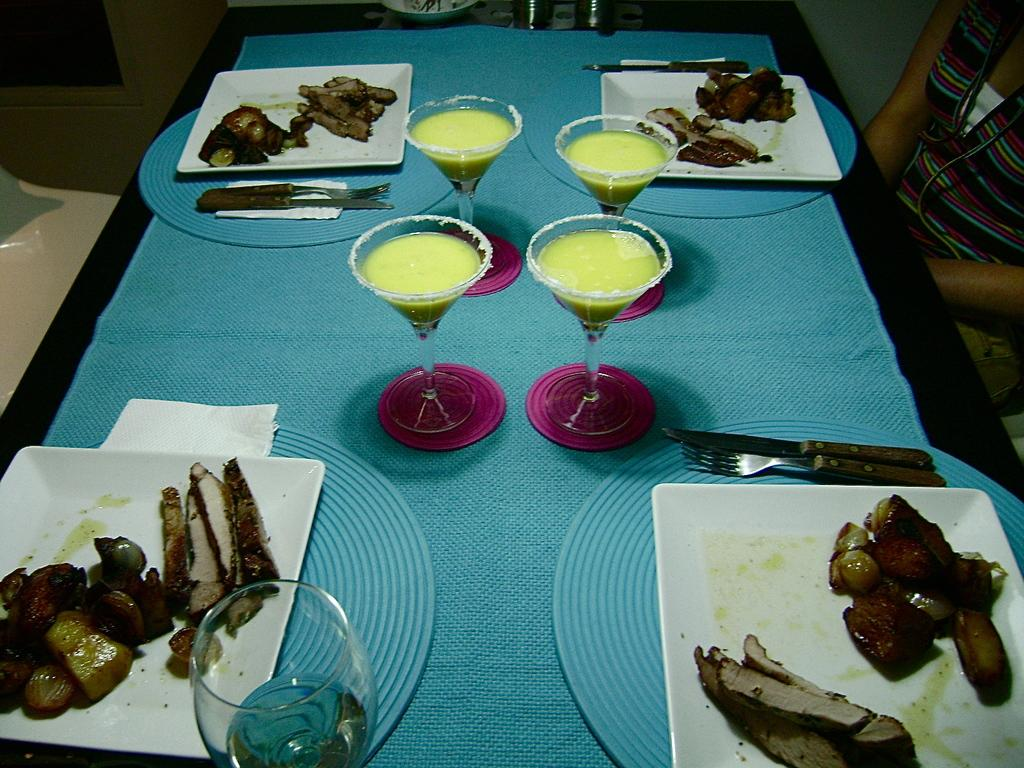What type of plates are on the table in the image? There are white plates on the table. What type of food can be seen on the table? There is meat and potatoes on the table. What utensils are available on the table? There are knives and forks on the table. What can be used for cleaning or wiping on the table? There are tissue papers on the table. What is the woman near the wall doing? The image does not show the woman's actions or activities. What type of moon can be seen in the image? There is no moon visible in the image. What is the woman using to generate electricity in the image? The image does not show the woman using any device to generate electricity. 